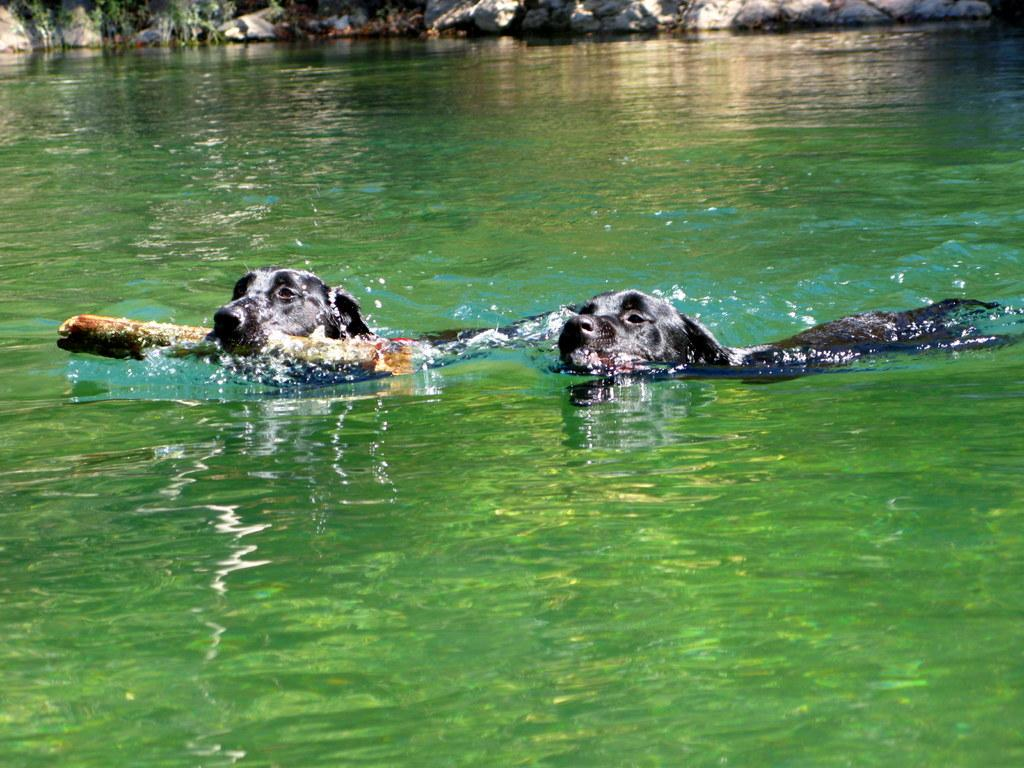How many dogs are present in the image? There are two dogs in the image. What are the dogs doing in the image? The dogs are in the water, and one dog is biting a wood piece. What can be seen in the background of the image? There are rocks visible in the background of the image. What type of fuel is being used by the zebra in the image? There is no zebra present in the image, so the question about fuel cannot be answered. What verse is being recited by the dogs in the image? The dogs in the image are not reciting any verses; they are in the water and interacting with a wood piece. 